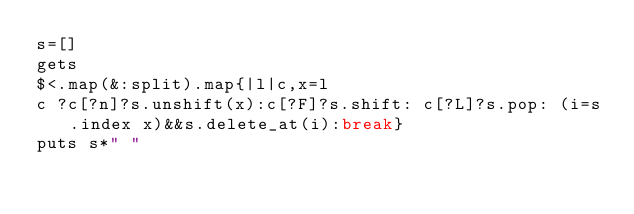Convert code to text. <code><loc_0><loc_0><loc_500><loc_500><_Ruby_>s=[]
gets
$<.map(&:split).map{|l|c,x=l
c ?c[?n]?s.unshift(x):c[?F]?s.shift: c[?L]?s.pop: (i=s.index x)&&s.delete_at(i):break}
puts s*" "</code> 